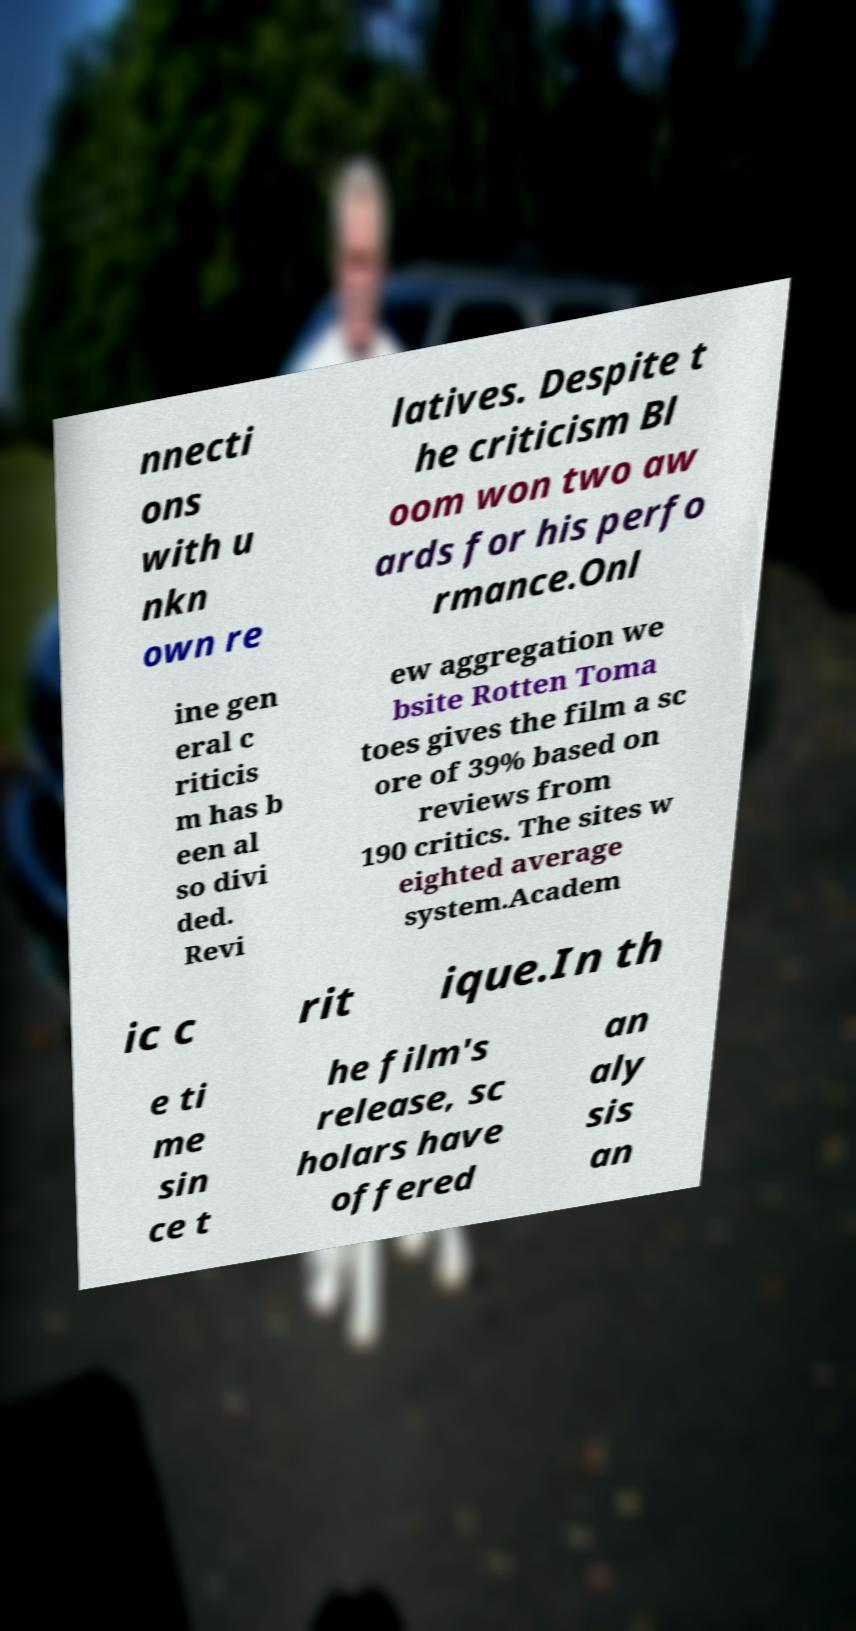I need the written content from this picture converted into text. Can you do that? nnecti ons with u nkn own re latives. Despite t he criticism Bl oom won two aw ards for his perfo rmance.Onl ine gen eral c riticis m has b een al so divi ded. Revi ew aggregation we bsite Rotten Toma toes gives the film a sc ore of 39% based on reviews from 190 critics. The sites w eighted average system.Academ ic c rit ique.In th e ti me sin ce t he film's release, sc holars have offered an aly sis an 